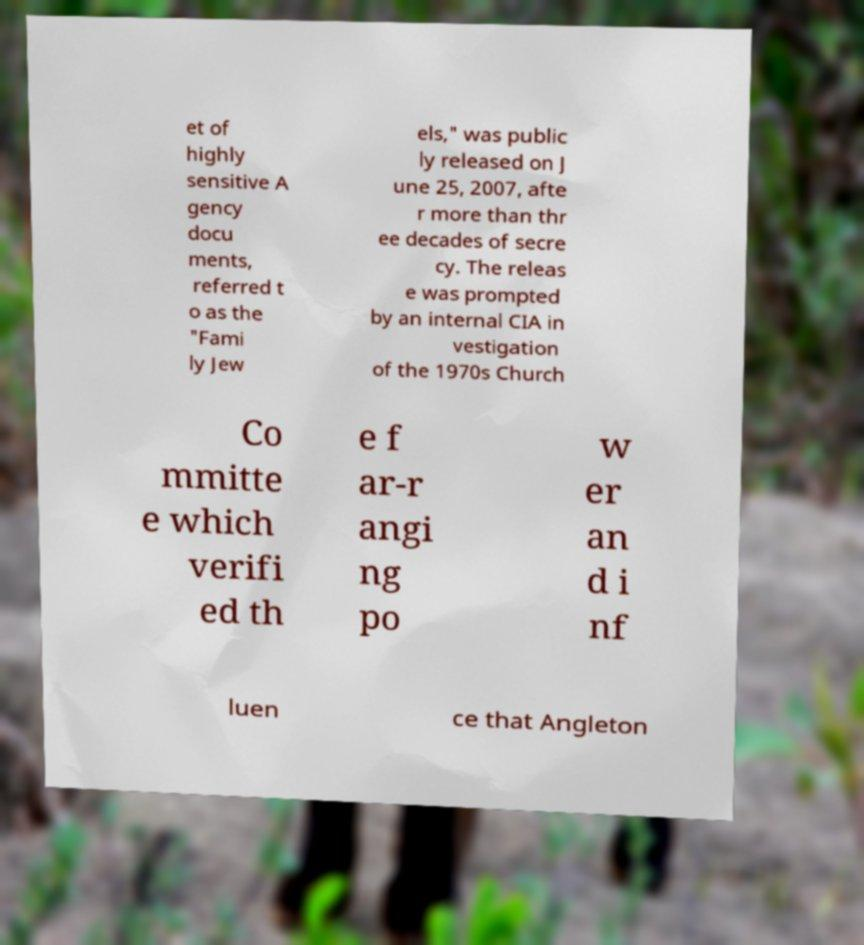For documentation purposes, I need the text within this image transcribed. Could you provide that? et of highly sensitive A gency docu ments, referred t o as the "Fami ly Jew els," was public ly released on J une 25, 2007, afte r more than thr ee decades of secre cy. The releas e was prompted by an internal CIA in vestigation of the 1970s Church Co mmitte e which verifi ed th e f ar-r angi ng po w er an d i nf luen ce that Angleton 